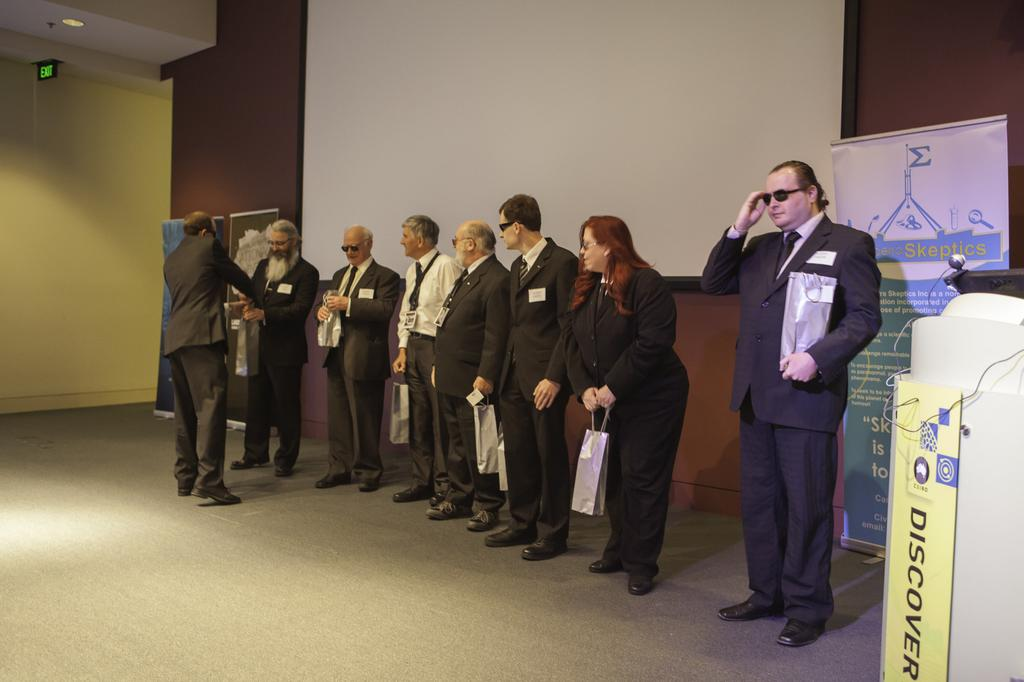What is happening in the image? There is a group of people in the image, and they are standing on a stage. What can be seen behind the people on the stage? There are banners behind the people on the stage. What religious beliefs are being discussed by the people on the stage? There is no indication of any religious beliefs being discussed in the image, as the focus is on the group of people standing on the stage and the banners behind them. 